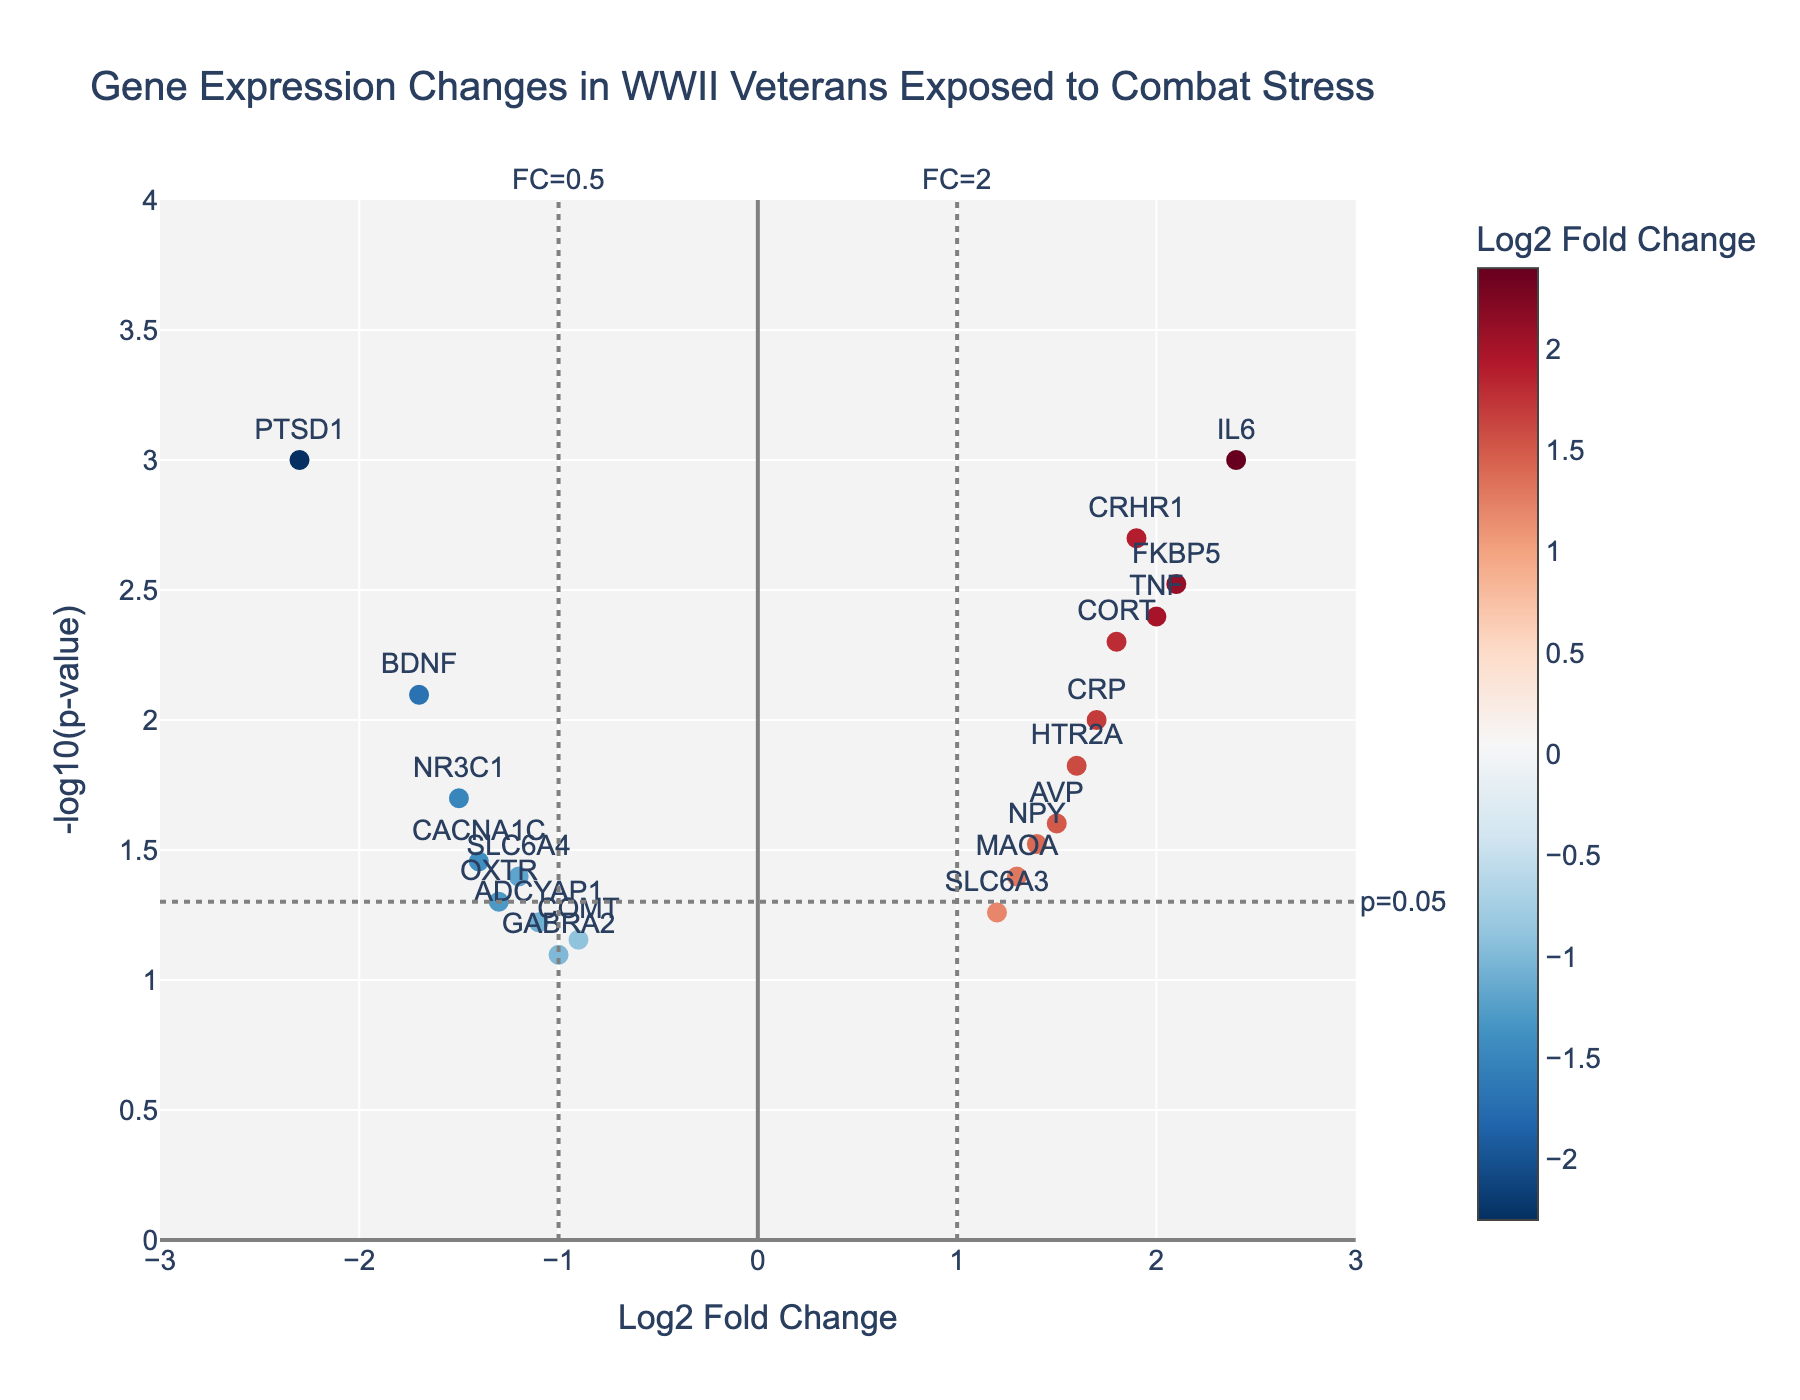How many genes are shown in the plot? Count the number of data points labeled with gene names in the scatter plot.
Answer: 20 Which gene has the highest log2 fold change? Look for the gene with the highest value on the x-axis (positive side). The gene must have the highest log2 fold change value.
Answer: IL6 What is the y-axis representing? The y-axis is labeled as "-log10(p-value)", indicating that it shows the negative logarithm to the base 10 of the p-values associated with each gene.
Answer: -log10(p-value) How many genes show a statistically significant change at p<0.05? Check the number of genes above the horizontal line marked by the threshold for p=0.05 on the plot. Count these genes.
Answer: 12 Which genes have a log2 fold change greater than 1 and also statistically significant with p<0.05? Find genes that are both to the right of log2 fold change (FC) = 1 (vertical line) and above the horizontal line for p=0.05.
Answer: IL6, TNF, FKBP5, CRHR1, CORT Between CRHR1 and BDNF, which gene shows a higher fold change? Compare the x-axis values of CRHR1 and BDNF. CRHR1 has a more positive value indicating a higher fold change.
Answer: CRHR1 What is the log2 fold change for the gene PTDS1? Identify the x-axis value corresponding to the gene PTDS1. It is labeled on the plot.
Answer: -2.3 Which gene has the smallest p-value? The gene with the highest y-axis value ("-log10(p-value)") has the smallest p-value.
Answer: IL6 How is the color of the data points determined? The color represents the log2 fold change values, as indicated by the color bar labeled "Log2 Fold Change".
Answer: Log2 Fold Change Identify genes that are down-regulated (negative log2 fold change) and statistically significant with p<0.05. Find genes with negative x-axis values that are also above the p=0.05 threshold (horizontal line).
Answer: PTSD1, NR3C1, BDNF 